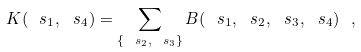Convert formula to latex. <formula><loc_0><loc_0><loc_500><loc_500>K ( \ s _ { 1 } , \ s _ { 4 } ) = \sum _ { \{ \ s _ { 2 } , \ s _ { 3 } \} } B ( \ s _ { 1 } , \ s _ { 2 } , \ s _ { 3 } , \ s _ { 4 } ) \ ,</formula> 